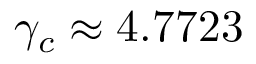Convert formula to latex. <formula><loc_0><loc_0><loc_500><loc_500>\gamma _ { c } \approx 4 . 7 7 2 3</formula> 